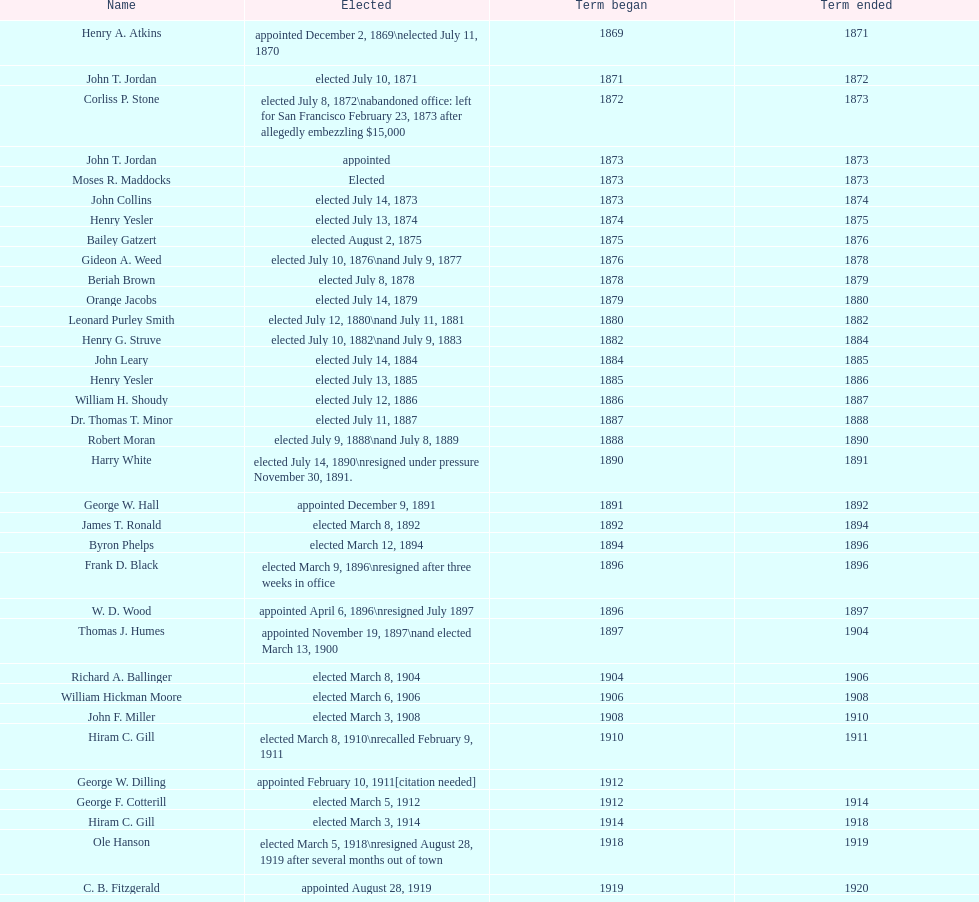How many days did robert moran serve? 365. 